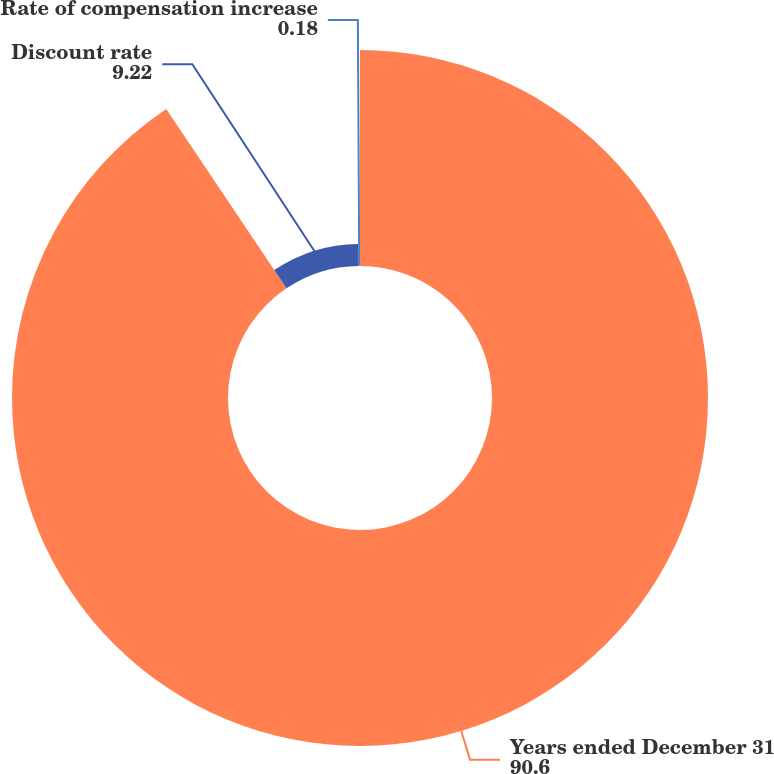Convert chart to OTSL. <chart><loc_0><loc_0><loc_500><loc_500><pie_chart><fcel>Years ended December 31<fcel>Discount rate<fcel>Rate of compensation increase<nl><fcel>90.6%<fcel>9.22%<fcel>0.18%<nl></chart> 